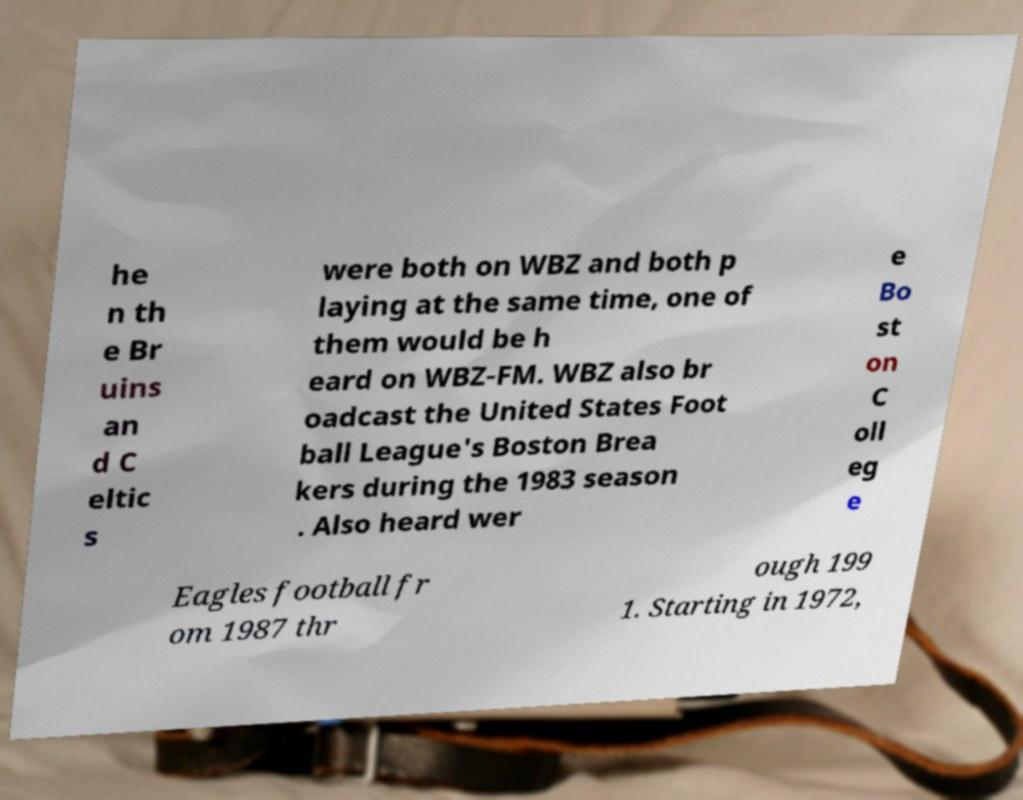I need the written content from this picture converted into text. Can you do that? he n th e Br uins an d C eltic s were both on WBZ and both p laying at the same time, one of them would be h eard on WBZ-FM. WBZ also br oadcast the United States Foot ball League's Boston Brea kers during the 1983 season . Also heard wer e Bo st on C oll eg e Eagles football fr om 1987 thr ough 199 1. Starting in 1972, 